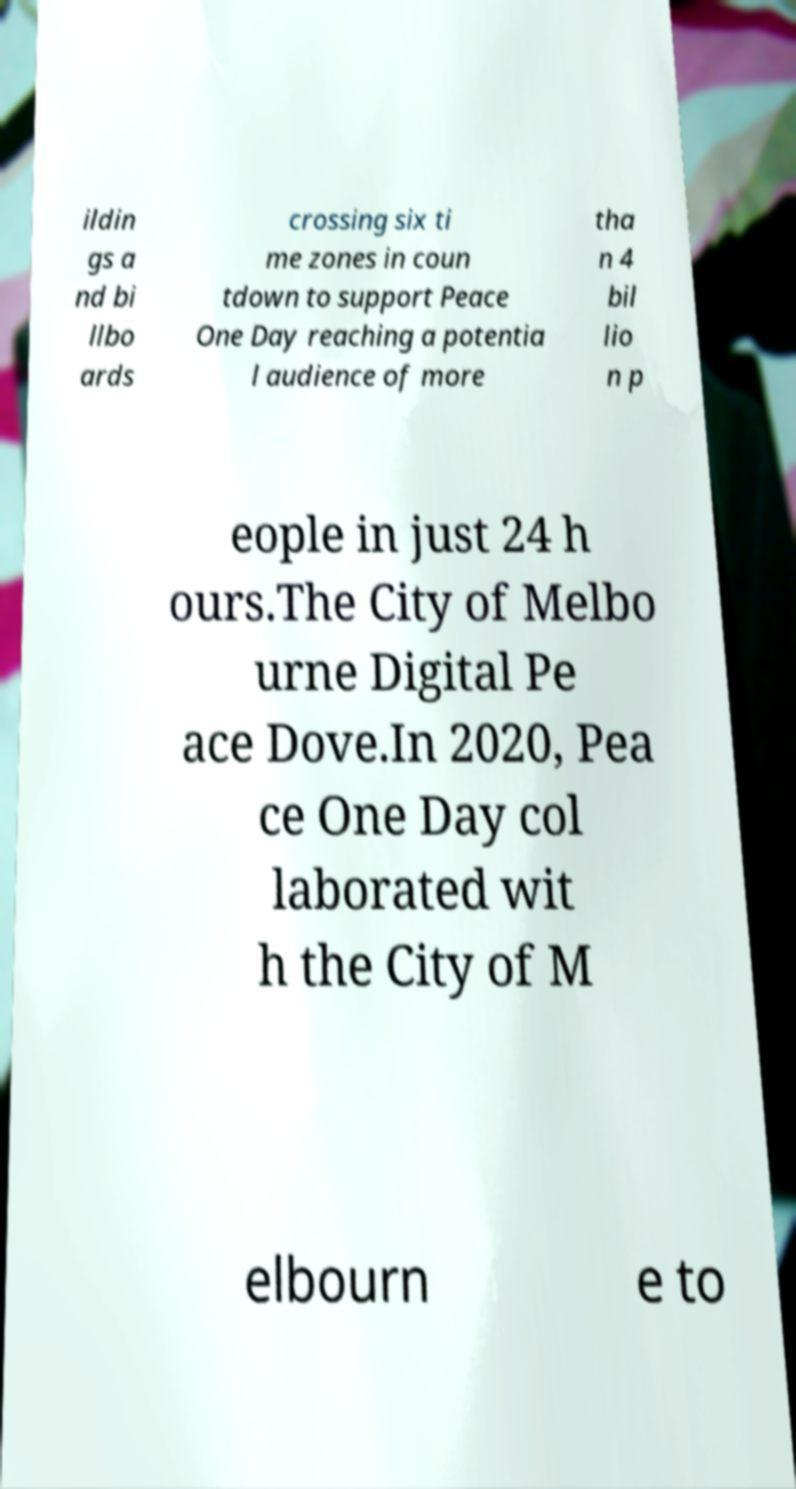What messages or text are displayed in this image? I need them in a readable, typed format. ildin gs a nd bi llbo ards crossing six ti me zones in coun tdown to support Peace One Day reaching a potentia l audience of more tha n 4 bil lio n p eople in just 24 h ours.The City of Melbo urne Digital Pe ace Dove.In 2020, Pea ce One Day col laborated wit h the City of M elbourn e to 